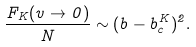<formula> <loc_0><loc_0><loc_500><loc_500>\frac { F _ { K } ( v \to 0 ) } { N } \sim ( b - b _ { c } ^ { K } ) ^ { 2 } .</formula> 